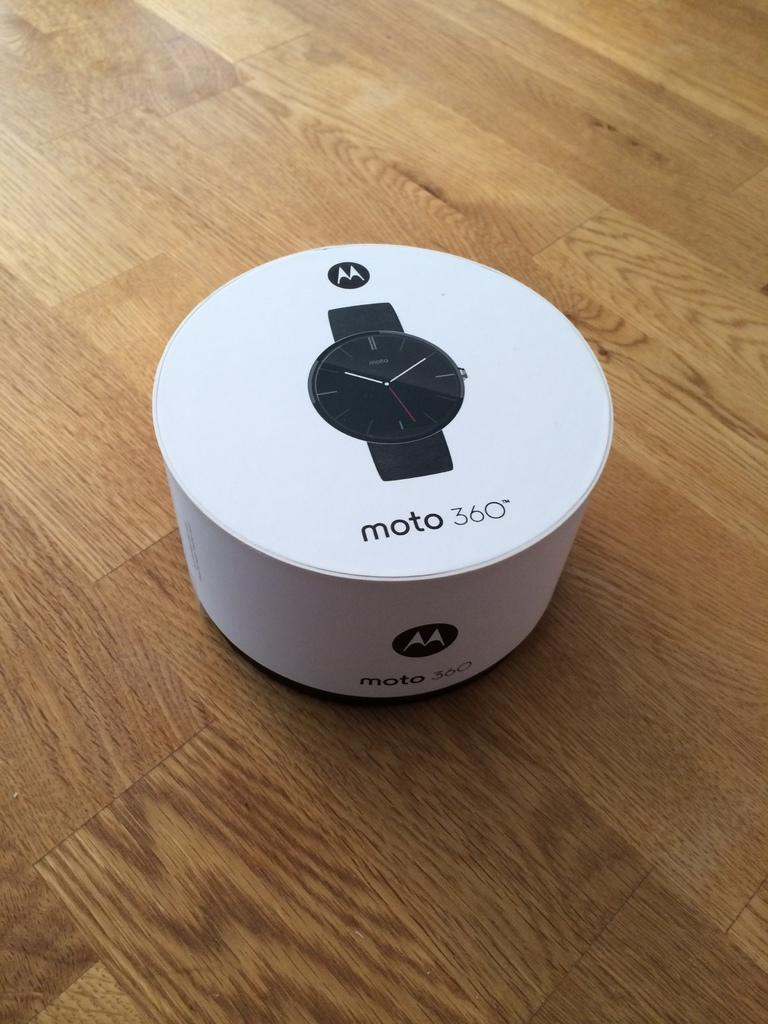<image>
Give a short and clear explanation of the subsequent image. A round container for a moto 360 watch sits on a wooden floor. 